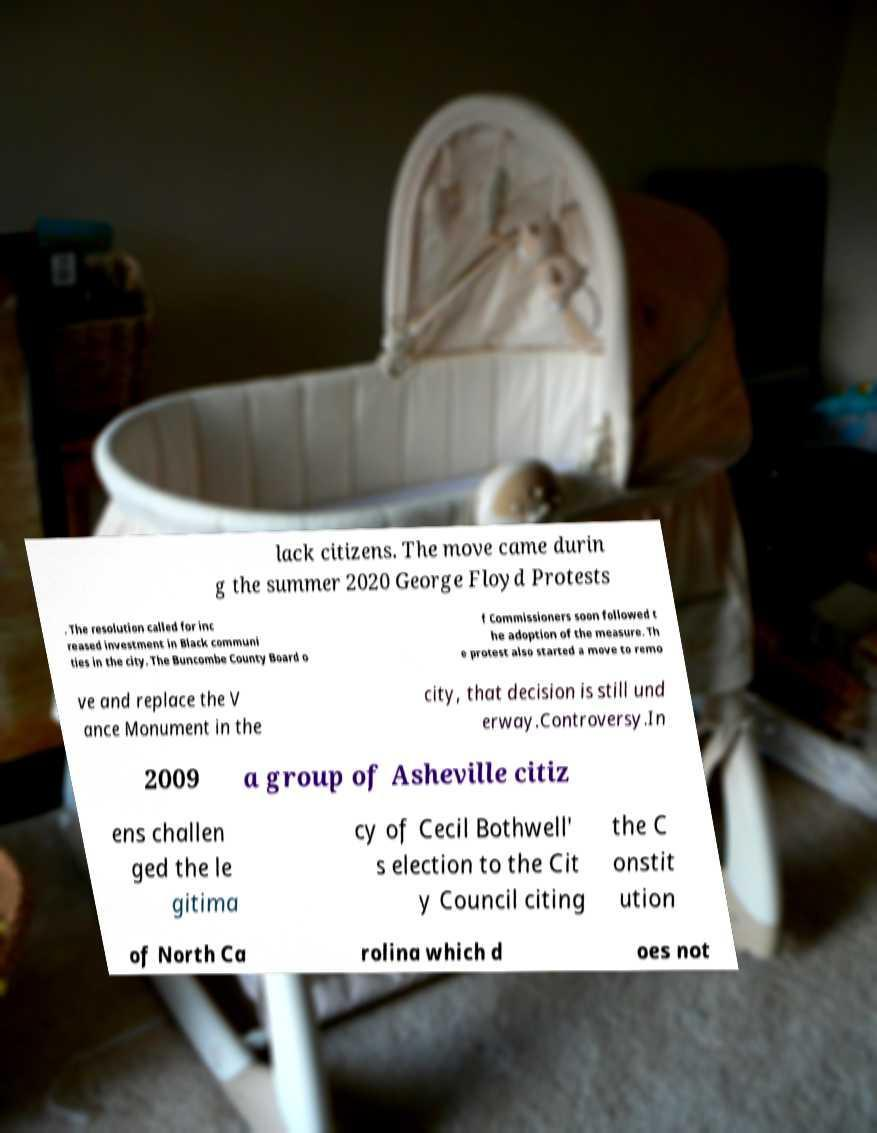Can you accurately transcribe the text from the provided image for me? lack citizens. The move came durin g the summer 2020 George Floyd Protests . The resolution called for inc reased investment in Black communi ties in the city. The Buncombe County Board o f Commissioners soon followed t he adoption of the measure. Th e protest also started a move to remo ve and replace the V ance Monument in the city, that decision is still und erway.Controversy.In 2009 a group of Asheville citiz ens challen ged the le gitima cy of Cecil Bothwell' s election to the Cit y Council citing the C onstit ution of North Ca rolina which d oes not 